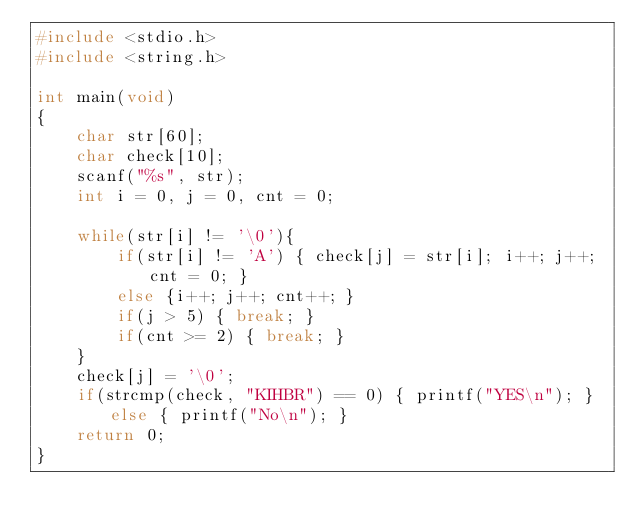<code> <loc_0><loc_0><loc_500><loc_500><_C_>#include <stdio.h>
#include <string.h>

int main(void)
{
    char str[60];
    char check[10];
    scanf("%s", str);
    int i = 0, j = 0, cnt = 0;
    
    while(str[i] != '\0'){
        if(str[i] != 'A') { check[j] = str[i]; i++; j++; cnt = 0; }
        else {i++; j++; cnt++; }
        if(j > 5) { break; }
        if(cnt >= 2) { break; }
    }
    check[j] = '\0';
    if(strcmp(check, "KIHBR") == 0) { printf("YES\n"); } else { printf("No\n"); }
    return 0;
}</code> 